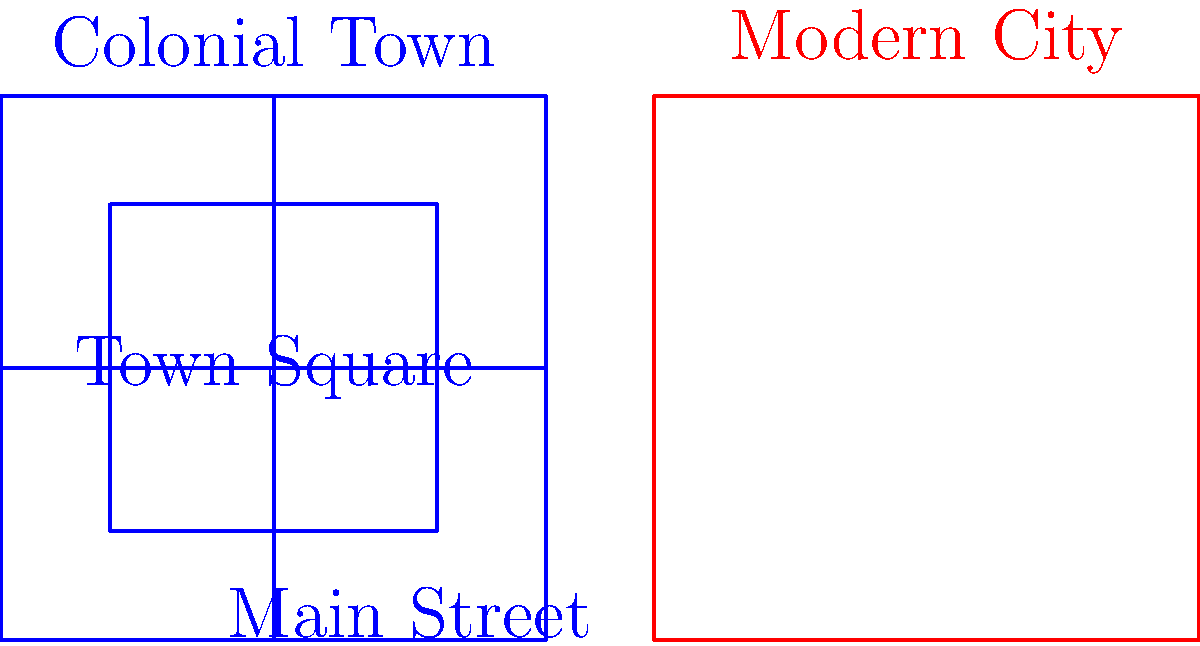Compare the layout of a typical colonial town to a modern city plan. What are the key differences in organization and land use that reflect changes in urban planning over time? 1. Town Square vs. Grid System:
   - Colonial town: Centered around a large town square
   - Modern city: Organized in a grid pattern with multiple blocks

2. Street Layout:
   - Colonial town: Few main streets radiating from the central square
   - Modern city: Numerous intersecting streets forming a grid

3. Green Spaces:
   - Colonial town: Large central green (town square)
   - Modern city: Smaller, distributed parks throughout the city

4. Building Density:
   - Colonial town: Lower density, buildings clustered around the square
   - Modern city: Higher density, buildings spread throughout the grid

5. Land Use:
   - Colonial town: Mixed-use center with clear town boundaries
   - Modern city: Zoned areas for different purposes (residential, commercial, industrial)

6. Scale:
   - Colonial town: Smaller, walkable scale
   - Modern city: Larger scale, often requiring transportation between areas

7. Adaptability:
   - Colonial town: Limited room for expansion
   - Modern city: Grid system allows for easier growth and development

These differences reflect changes in transportation, population growth, and urban planning philosophies over time.
Answer: Modern cities have grid layouts with distributed amenities, while colonial towns were centered around a town square with radial streets. 